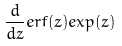Convert formula to latex. <formula><loc_0><loc_0><loc_500><loc_500>\frac { d } { d z } e r f ( z ) e x p ( z )</formula> 